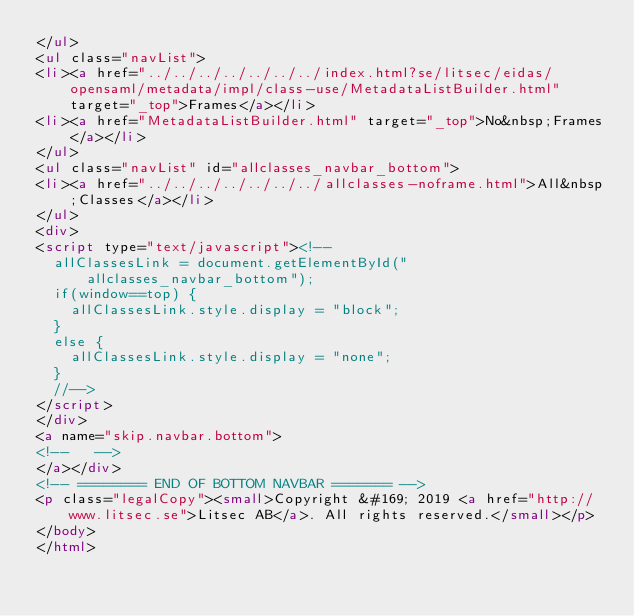Convert code to text. <code><loc_0><loc_0><loc_500><loc_500><_HTML_></ul>
<ul class="navList">
<li><a href="../../../../../../../index.html?se/litsec/eidas/opensaml/metadata/impl/class-use/MetadataListBuilder.html" target="_top">Frames</a></li>
<li><a href="MetadataListBuilder.html" target="_top">No&nbsp;Frames</a></li>
</ul>
<ul class="navList" id="allclasses_navbar_bottom">
<li><a href="../../../../../../../allclasses-noframe.html">All&nbsp;Classes</a></li>
</ul>
<div>
<script type="text/javascript"><!--
  allClassesLink = document.getElementById("allclasses_navbar_bottom");
  if(window==top) {
    allClassesLink.style.display = "block";
  }
  else {
    allClassesLink.style.display = "none";
  }
  //-->
</script>
</div>
<a name="skip.navbar.bottom">
<!--   -->
</a></div>
<!-- ======== END OF BOTTOM NAVBAR ======= -->
<p class="legalCopy"><small>Copyright &#169; 2019 <a href="http://www.litsec.se">Litsec AB</a>. All rights reserved.</small></p>
</body>
</html>
</code> 